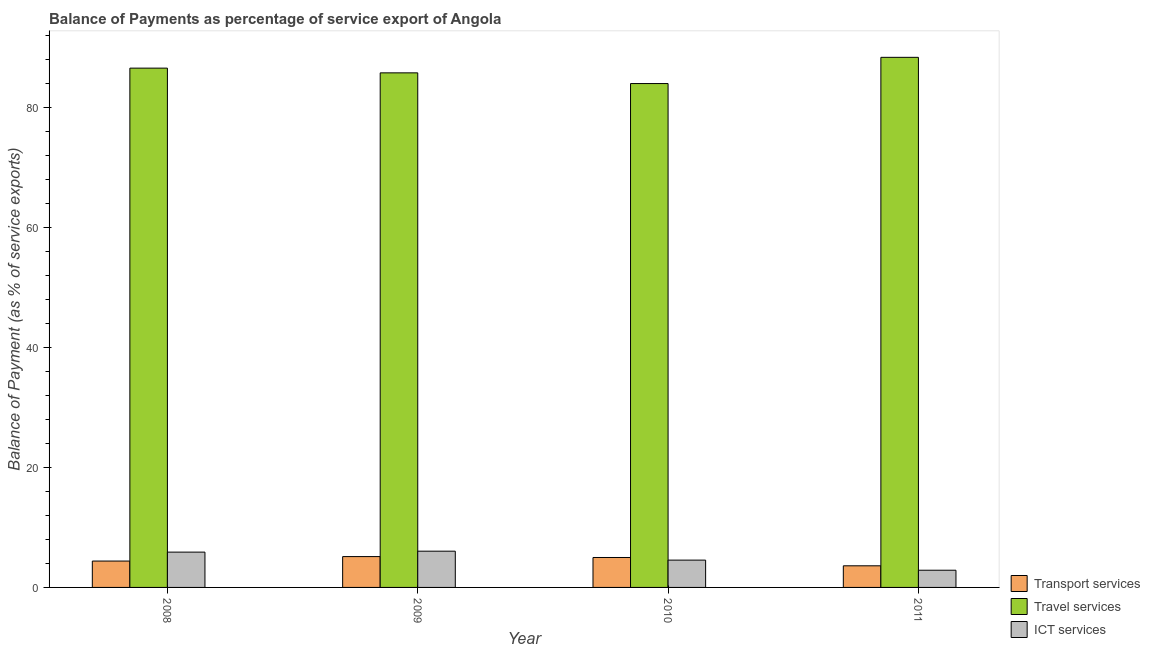Are the number of bars on each tick of the X-axis equal?
Make the answer very short. Yes. What is the label of the 4th group of bars from the left?
Make the answer very short. 2011. What is the balance of payment of ict services in 2011?
Offer a very short reply. 2.87. Across all years, what is the maximum balance of payment of travel services?
Keep it short and to the point. 88.28. Across all years, what is the minimum balance of payment of ict services?
Your response must be concise. 2.87. In which year was the balance of payment of ict services maximum?
Offer a very short reply. 2009. What is the total balance of payment of travel services in the graph?
Provide a short and direct response. 344.39. What is the difference between the balance of payment of ict services in 2008 and that in 2011?
Your response must be concise. 3.02. What is the difference between the balance of payment of travel services in 2010 and the balance of payment of transport services in 2008?
Give a very brief answer. -2.57. What is the average balance of payment of travel services per year?
Ensure brevity in your answer.  86.1. What is the ratio of the balance of payment of travel services in 2008 to that in 2009?
Your answer should be very brief. 1.01. Is the balance of payment of ict services in 2008 less than that in 2009?
Offer a terse response. Yes. Is the difference between the balance of payment of ict services in 2009 and 2011 greater than the difference between the balance of payment of transport services in 2009 and 2011?
Provide a succinct answer. No. What is the difference between the highest and the second highest balance of payment of transport services?
Offer a terse response. 0.15. What is the difference between the highest and the lowest balance of payment of travel services?
Provide a short and direct response. 4.37. What does the 1st bar from the left in 2009 represents?
Offer a very short reply. Transport services. What does the 1st bar from the right in 2011 represents?
Provide a succinct answer. ICT services. How many bars are there?
Ensure brevity in your answer.  12. What is the difference between two consecutive major ticks on the Y-axis?
Provide a short and direct response. 20. Does the graph contain any zero values?
Your answer should be very brief. No. How many legend labels are there?
Provide a succinct answer. 3. How are the legend labels stacked?
Offer a terse response. Vertical. What is the title of the graph?
Your answer should be compact. Balance of Payments as percentage of service export of Angola. Does "Machinery" appear as one of the legend labels in the graph?
Offer a very short reply. No. What is the label or title of the X-axis?
Make the answer very short. Year. What is the label or title of the Y-axis?
Offer a terse response. Balance of Payment (as % of service exports). What is the Balance of Payment (as % of service exports) of Transport services in 2008?
Your response must be concise. 4.39. What is the Balance of Payment (as % of service exports) of Travel services in 2008?
Offer a terse response. 86.48. What is the Balance of Payment (as % of service exports) of ICT services in 2008?
Your answer should be compact. 5.88. What is the Balance of Payment (as % of service exports) of Transport services in 2009?
Your response must be concise. 5.14. What is the Balance of Payment (as % of service exports) in Travel services in 2009?
Your response must be concise. 85.7. What is the Balance of Payment (as % of service exports) of ICT services in 2009?
Your answer should be compact. 6.04. What is the Balance of Payment (as % of service exports) in Transport services in 2010?
Keep it short and to the point. 4.98. What is the Balance of Payment (as % of service exports) in Travel services in 2010?
Your answer should be compact. 83.92. What is the Balance of Payment (as % of service exports) of ICT services in 2010?
Make the answer very short. 4.55. What is the Balance of Payment (as % of service exports) in Transport services in 2011?
Your answer should be very brief. 3.6. What is the Balance of Payment (as % of service exports) of Travel services in 2011?
Your answer should be very brief. 88.28. What is the Balance of Payment (as % of service exports) of ICT services in 2011?
Your answer should be compact. 2.87. Across all years, what is the maximum Balance of Payment (as % of service exports) of Transport services?
Offer a terse response. 5.14. Across all years, what is the maximum Balance of Payment (as % of service exports) of Travel services?
Keep it short and to the point. 88.28. Across all years, what is the maximum Balance of Payment (as % of service exports) in ICT services?
Ensure brevity in your answer.  6.04. Across all years, what is the minimum Balance of Payment (as % of service exports) in Transport services?
Provide a succinct answer. 3.6. Across all years, what is the minimum Balance of Payment (as % of service exports) in Travel services?
Keep it short and to the point. 83.92. Across all years, what is the minimum Balance of Payment (as % of service exports) of ICT services?
Your response must be concise. 2.87. What is the total Balance of Payment (as % of service exports) in Transport services in the graph?
Provide a succinct answer. 18.11. What is the total Balance of Payment (as % of service exports) in Travel services in the graph?
Your response must be concise. 344.38. What is the total Balance of Payment (as % of service exports) of ICT services in the graph?
Give a very brief answer. 19.33. What is the difference between the Balance of Payment (as % of service exports) of Transport services in 2008 and that in 2009?
Your answer should be compact. -0.74. What is the difference between the Balance of Payment (as % of service exports) in Travel services in 2008 and that in 2009?
Provide a short and direct response. 0.79. What is the difference between the Balance of Payment (as % of service exports) of ICT services in 2008 and that in 2009?
Provide a short and direct response. -0.16. What is the difference between the Balance of Payment (as % of service exports) in Transport services in 2008 and that in 2010?
Offer a very short reply. -0.59. What is the difference between the Balance of Payment (as % of service exports) of Travel services in 2008 and that in 2010?
Ensure brevity in your answer.  2.57. What is the difference between the Balance of Payment (as % of service exports) of ICT services in 2008 and that in 2010?
Ensure brevity in your answer.  1.33. What is the difference between the Balance of Payment (as % of service exports) of Transport services in 2008 and that in 2011?
Provide a short and direct response. 0.79. What is the difference between the Balance of Payment (as % of service exports) in Travel services in 2008 and that in 2011?
Your response must be concise. -1.8. What is the difference between the Balance of Payment (as % of service exports) in ICT services in 2008 and that in 2011?
Make the answer very short. 3.02. What is the difference between the Balance of Payment (as % of service exports) in Transport services in 2009 and that in 2010?
Keep it short and to the point. 0.15. What is the difference between the Balance of Payment (as % of service exports) in Travel services in 2009 and that in 2010?
Provide a succinct answer. 1.78. What is the difference between the Balance of Payment (as % of service exports) in ICT services in 2009 and that in 2010?
Provide a short and direct response. 1.49. What is the difference between the Balance of Payment (as % of service exports) of Transport services in 2009 and that in 2011?
Make the answer very short. 1.53. What is the difference between the Balance of Payment (as % of service exports) in Travel services in 2009 and that in 2011?
Provide a succinct answer. -2.59. What is the difference between the Balance of Payment (as % of service exports) in ICT services in 2009 and that in 2011?
Ensure brevity in your answer.  3.17. What is the difference between the Balance of Payment (as % of service exports) of Transport services in 2010 and that in 2011?
Your answer should be compact. 1.38. What is the difference between the Balance of Payment (as % of service exports) of Travel services in 2010 and that in 2011?
Make the answer very short. -4.37. What is the difference between the Balance of Payment (as % of service exports) in ICT services in 2010 and that in 2011?
Give a very brief answer. 1.68. What is the difference between the Balance of Payment (as % of service exports) of Transport services in 2008 and the Balance of Payment (as % of service exports) of Travel services in 2009?
Keep it short and to the point. -81.31. What is the difference between the Balance of Payment (as % of service exports) of Transport services in 2008 and the Balance of Payment (as % of service exports) of ICT services in 2009?
Make the answer very short. -1.64. What is the difference between the Balance of Payment (as % of service exports) in Travel services in 2008 and the Balance of Payment (as % of service exports) in ICT services in 2009?
Your response must be concise. 80.45. What is the difference between the Balance of Payment (as % of service exports) of Transport services in 2008 and the Balance of Payment (as % of service exports) of Travel services in 2010?
Your answer should be compact. -79.52. What is the difference between the Balance of Payment (as % of service exports) in Transport services in 2008 and the Balance of Payment (as % of service exports) in ICT services in 2010?
Provide a succinct answer. -0.15. What is the difference between the Balance of Payment (as % of service exports) in Travel services in 2008 and the Balance of Payment (as % of service exports) in ICT services in 2010?
Your response must be concise. 81.94. What is the difference between the Balance of Payment (as % of service exports) of Transport services in 2008 and the Balance of Payment (as % of service exports) of Travel services in 2011?
Your answer should be very brief. -83.89. What is the difference between the Balance of Payment (as % of service exports) in Transport services in 2008 and the Balance of Payment (as % of service exports) in ICT services in 2011?
Your answer should be compact. 1.53. What is the difference between the Balance of Payment (as % of service exports) of Travel services in 2008 and the Balance of Payment (as % of service exports) of ICT services in 2011?
Your answer should be very brief. 83.62. What is the difference between the Balance of Payment (as % of service exports) in Transport services in 2009 and the Balance of Payment (as % of service exports) in Travel services in 2010?
Your answer should be very brief. -78.78. What is the difference between the Balance of Payment (as % of service exports) in Transport services in 2009 and the Balance of Payment (as % of service exports) in ICT services in 2010?
Offer a very short reply. 0.59. What is the difference between the Balance of Payment (as % of service exports) in Travel services in 2009 and the Balance of Payment (as % of service exports) in ICT services in 2010?
Your answer should be very brief. 81.15. What is the difference between the Balance of Payment (as % of service exports) in Transport services in 2009 and the Balance of Payment (as % of service exports) in Travel services in 2011?
Offer a terse response. -83.15. What is the difference between the Balance of Payment (as % of service exports) in Transport services in 2009 and the Balance of Payment (as % of service exports) in ICT services in 2011?
Your answer should be compact. 2.27. What is the difference between the Balance of Payment (as % of service exports) of Travel services in 2009 and the Balance of Payment (as % of service exports) of ICT services in 2011?
Your answer should be very brief. 82.83. What is the difference between the Balance of Payment (as % of service exports) in Transport services in 2010 and the Balance of Payment (as % of service exports) in Travel services in 2011?
Ensure brevity in your answer.  -83.3. What is the difference between the Balance of Payment (as % of service exports) of Transport services in 2010 and the Balance of Payment (as % of service exports) of ICT services in 2011?
Ensure brevity in your answer.  2.12. What is the difference between the Balance of Payment (as % of service exports) of Travel services in 2010 and the Balance of Payment (as % of service exports) of ICT services in 2011?
Your answer should be very brief. 81.05. What is the average Balance of Payment (as % of service exports) in Transport services per year?
Ensure brevity in your answer.  4.53. What is the average Balance of Payment (as % of service exports) in Travel services per year?
Your answer should be compact. 86.1. What is the average Balance of Payment (as % of service exports) in ICT services per year?
Offer a terse response. 4.83. In the year 2008, what is the difference between the Balance of Payment (as % of service exports) of Transport services and Balance of Payment (as % of service exports) of Travel services?
Give a very brief answer. -82.09. In the year 2008, what is the difference between the Balance of Payment (as % of service exports) in Transport services and Balance of Payment (as % of service exports) in ICT services?
Your answer should be compact. -1.49. In the year 2008, what is the difference between the Balance of Payment (as % of service exports) in Travel services and Balance of Payment (as % of service exports) in ICT services?
Ensure brevity in your answer.  80.6. In the year 2009, what is the difference between the Balance of Payment (as % of service exports) in Transport services and Balance of Payment (as % of service exports) in Travel services?
Ensure brevity in your answer.  -80.56. In the year 2009, what is the difference between the Balance of Payment (as % of service exports) of Transport services and Balance of Payment (as % of service exports) of ICT services?
Ensure brevity in your answer.  -0.9. In the year 2009, what is the difference between the Balance of Payment (as % of service exports) of Travel services and Balance of Payment (as % of service exports) of ICT services?
Your answer should be very brief. 79.66. In the year 2010, what is the difference between the Balance of Payment (as % of service exports) in Transport services and Balance of Payment (as % of service exports) in Travel services?
Keep it short and to the point. -78.93. In the year 2010, what is the difference between the Balance of Payment (as % of service exports) of Transport services and Balance of Payment (as % of service exports) of ICT services?
Give a very brief answer. 0.44. In the year 2010, what is the difference between the Balance of Payment (as % of service exports) in Travel services and Balance of Payment (as % of service exports) in ICT services?
Give a very brief answer. 79.37. In the year 2011, what is the difference between the Balance of Payment (as % of service exports) in Transport services and Balance of Payment (as % of service exports) in Travel services?
Your response must be concise. -84.68. In the year 2011, what is the difference between the Balance of Payment (as % of service exports) of Transport services and Balance of Payment (as % of service exports) of ICT services?
Offer a very short reply. 0.74. In the year 2011, what is the difference between the Balance of Payment (as % of service exports) in Travel services and Balance of Payment (as % of service exports) in ICT services?
Provide a short and direct response. 85.42. What is the ratio of the Balance of Payment (as % of service exports) in Transport services in 2008 to that in 2009?
Provide a short and direct response. 0.86. What is the ratio of the Balance of Payment (as % of service exports) of Travel services in 2008 to that in 2009?
Your answer should be very brief. 1.01. What is the ratio of the Balance of Payment (as % of service exports) in ICT services in 2008 to that in 2009?
Keep it short and to the point. 0.97. What is the ratio of the Balance of Payment (as % of service exports) of Transport services in 2008 to that in 2010?
Your response must be concise. 0.88. What is the ratio of the Balance of Payment (as % of service exports) in Travel services in 2008 to that in 2010?
Make the answer very short. 1.03. What is the ratio of the Balance of Payment (as % of service exports) in ICT services in 2008 to that in 2010?
Your response must be concise. 1.29. What is the ratio of the Balance of Payment (as % of service exports) in Transport services in 2008 to that in 2011?
Offer a very short reply. 1.22. What is the ratio of the Balance of Payment (as % of service exports) of Travel services in 2008 to that in 2011?
Ensure brevity in your answer.  0.98. What is the ratio of the Balance of Payment (as % of service exports) of ICT services in 2008 to that in 2011?
Provide a succinct answer. 2.05. What is the ratio of the Balance of Payment (as % of service exports) of Transport services in 2009 to that in 2010?
Provide a short and direct response. 1.03. What is the ratio of the Balance of Payment (as % of service exports) of Travel services in 2009 to that in 2010?
Your answer should be compact. 1.02. What is the ratio of the Balance of Payment (as % of service exports) in ICT services in 2009 to that in 2010?
Offer a very short reply. 1.33. What is the ratio of the Balance of Payment (as % of service exports) of Transport services in 2009 to that in 2011?
Provide a succinct answer. 1.43. What is the ratio of the Balance of Payment (as % of service exports) of Travel services in 2009 to that in 2011?
Offer a terse response. 0.97. What is the ratio of the Balance of Payment (as % of service exports) in ICT services in 2009 to that in 2011?
Your response must be concise. 2.11. What is the ratio of the Balance of Payment (as % of service exports) in Transport services in 2010 to that in 2011?
Your answer should be very brief. 1.38. What is the ratio of the Balance of Payment (as % of service exports) in Travel services in 2010 to that in 2011?
Make the answer very short. 0.95. What is the ratio of the Balance of Payment (as % of service exports) in ICT services in 2010 to that in 2011?
Provide a succinct answer. 1.59. What is the difference between the highest and the second highest Balance of Payment (as % of service exports) in Transport services?
Make the answer very short. 0.15. What is the difference between the highest and the second highest Balance of Payment (as % of service exports) in Travel services?
Keep it short and to the point. 1.8. What is the difference between the highest and the second highest Balance of Payment (as % of service exports) of ICT services?
Keep it short and to the point. 0.16. What is the difference between the highest and the lowest Balance of Payment (as % of service exports) in Transport services?
Offer a terse response. 1.53. What is the difference between the highest and the lowest Balance of Payment (as % of service exports) in Travel services?
Make the answer very short. 4.37. What is the difference between the highest and the lowest Balance of Payment (as % of service exports) in ICT services?
Your answer should be compact. 3.17. 